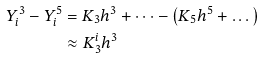Convert formula to latex. <formula><loc_0><loc_0><loc_500><loc_500>Y _ { i } ^ { 3 } - Y _ { i } ^ { 5 } & = K _ { 3 } h ^ { 3 } + \dots - \left ( K _ { 5 } h ^ { 5 } + \dots \right ) \\ & \approx K _ { 3 } ^ { i } h ^ { 3 }</formula> 